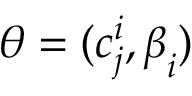<formula> <loc_0><loc_0><loc_500><loc_500>\boldsymbol \theta = ( c _ { j } ^ { i } , \boldsymbol \beta _ { i } )</formula> 